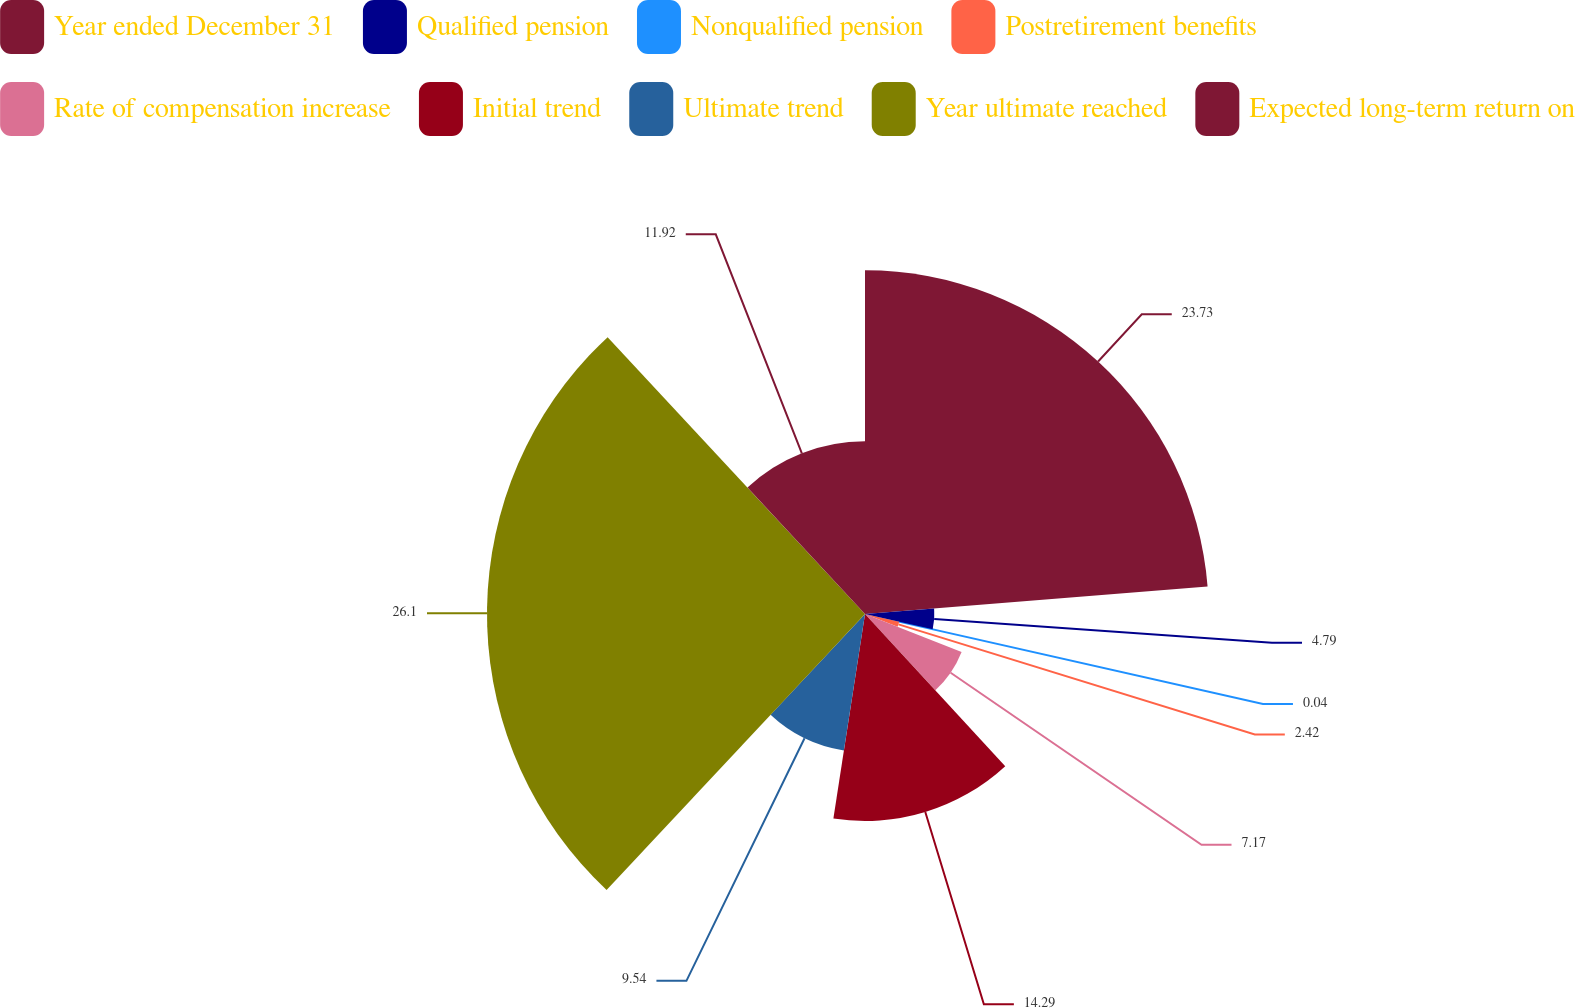<chart> <loc_0><loc_0><loc_500><loc_500><pie_chart><fcel>Year ended December 31<fcel>Qualified pension<fcel>Nonqualified pension<fcel>Postretirement benefits<fcel>Rate of compensation increase<fcel>Initial trend<fcel>Ultimate trend<fcel>Year ultimate reached<fcel>Expected long-term return on<nl><fcel>23.73%<fcel>4.79%<fcel>0.04%<fcel>2.42%<fcel>7.17%<fcel>14.29%<fcel>9.54%<fcel>26.1%<fcel>11.92%<nl></chart> 